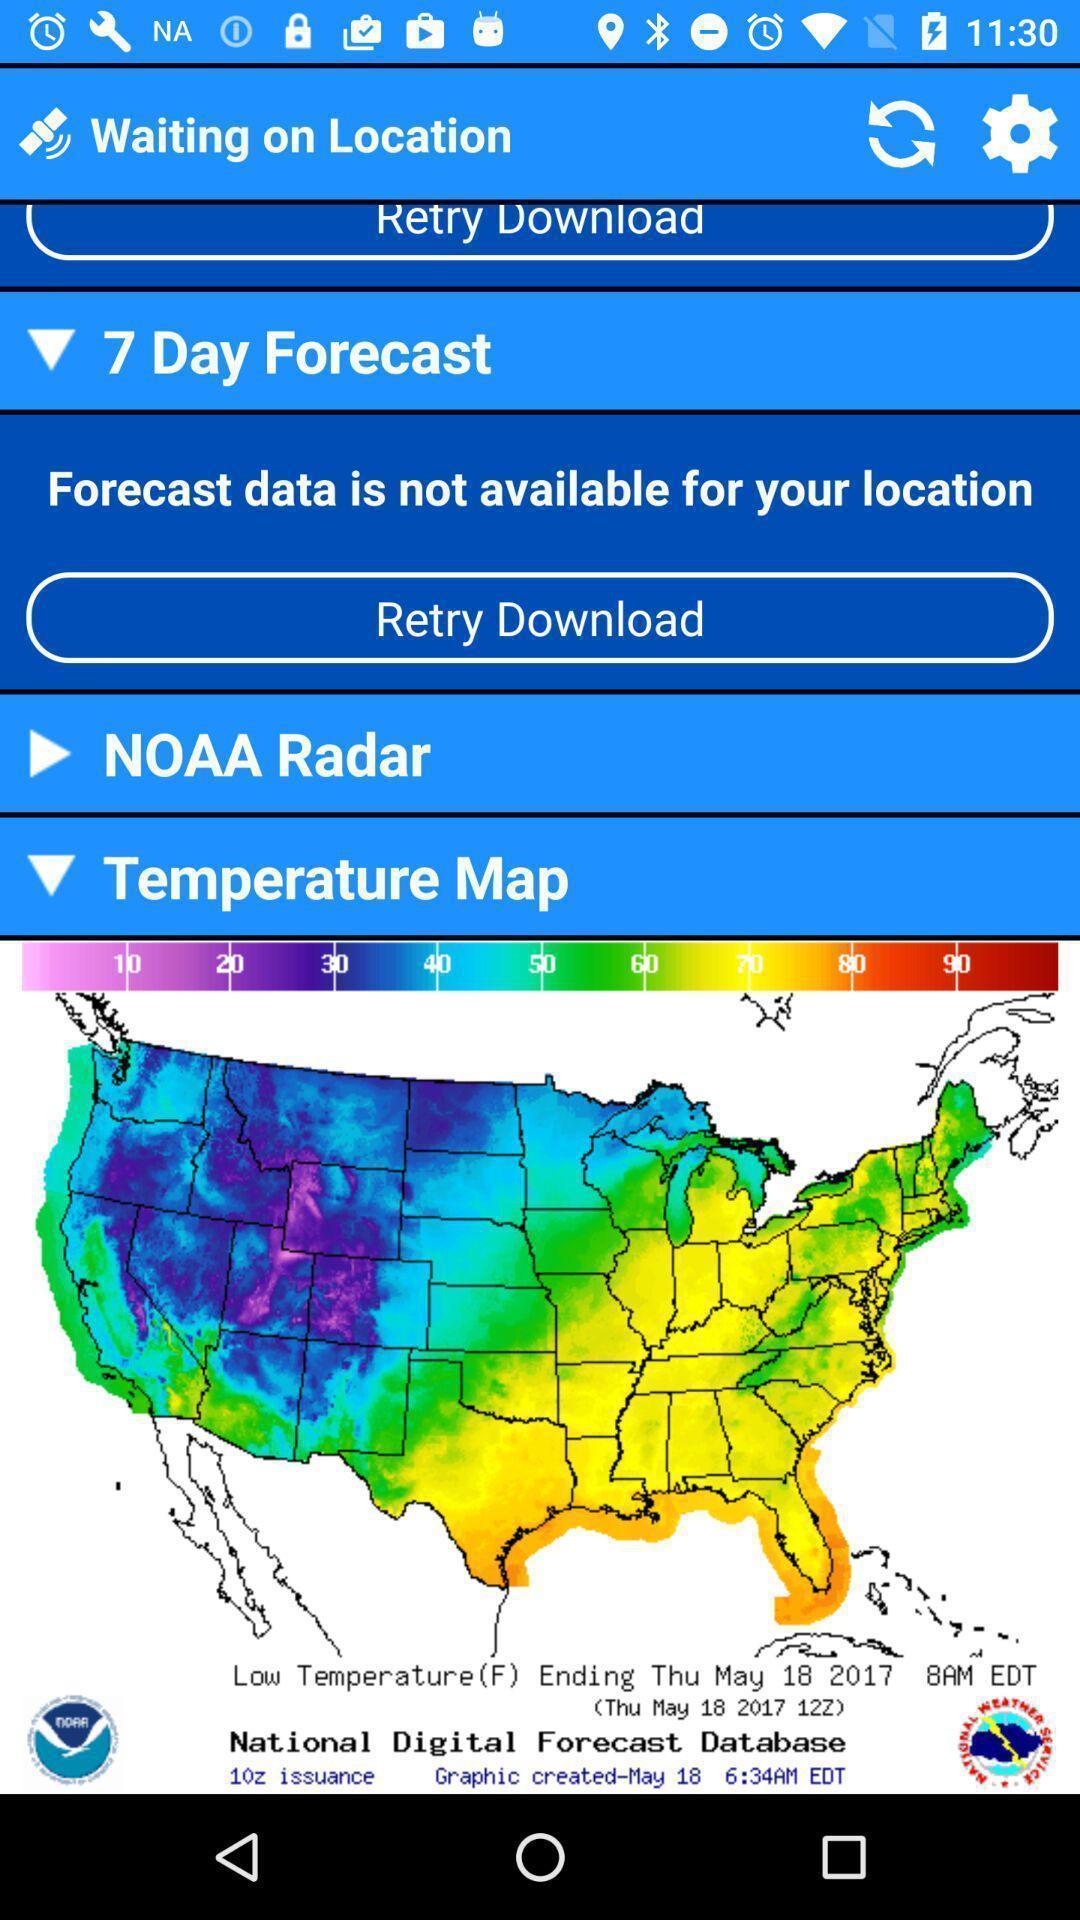Summarize the main components in this picture. Page displays the temperature map of a location. 